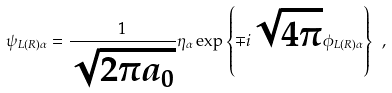Convert formula to latex. <formula><loc_0><loc_0><loc_500><loc_500>\psi _ { L ( R ) \alpha } = \frac { 1 } { \sqrt { 2 \pi a _ { 0 } } } \eta _ { \alpha } \exp { \left \{ \mp i \sqrt { 4 \pi } \phi _ { L ( R ) \alpha } \right \} } \ ,</formula> 